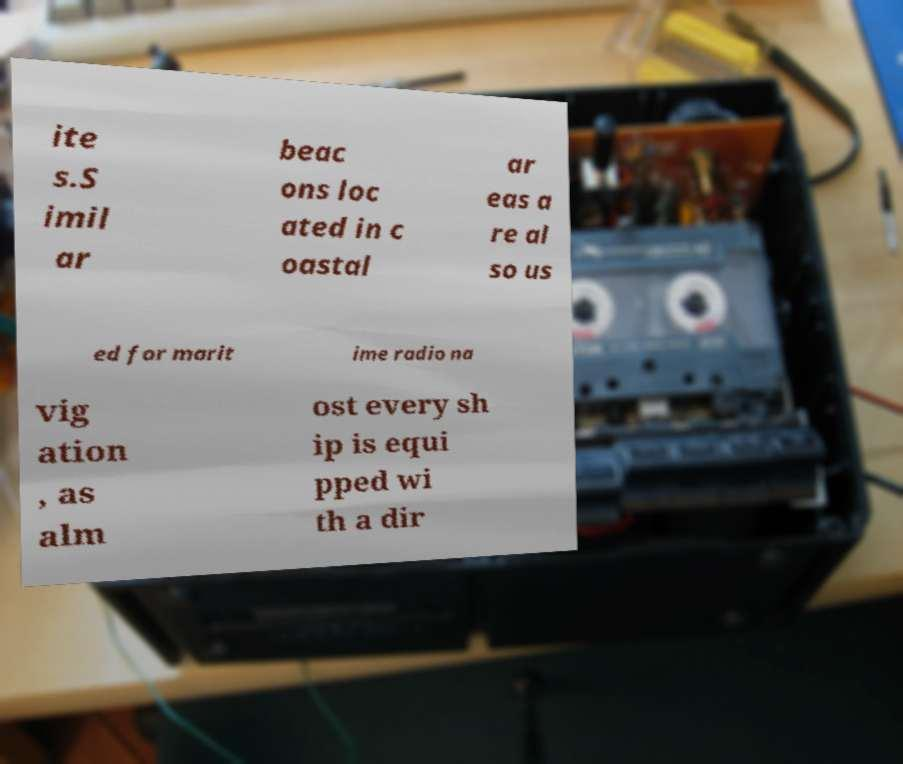Can you accurately transcribe the text from the provided image for me? ite s.S imil ar beac ons loc ated in c oastal ar eas a re al so us ed for marit ime radio na vig ation , as alm ost every sh ip is equi pped wi th a dir 